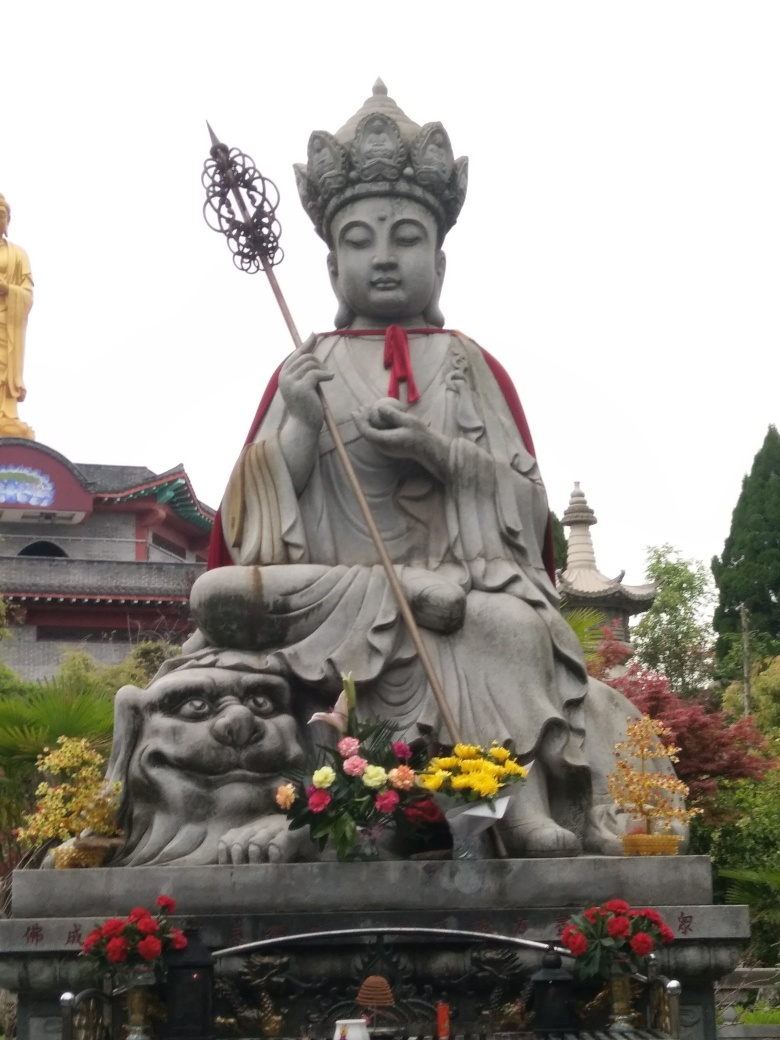Could you elaborate on the symbolism of the staff and the creature that the statue is seated upon? In many representations of Buddhist iconography, the staff held by deities or enlightened figures, such as bodhisattvas, symbolizes their ability to wield spiritual authority and the power to guide beings on the path to enlightenment. The staff may also represent the overcoming of obstacles. As for the creature at the base, it often signifies protection and support, with lion-like figures embodying strength and fearlessness. The presence of such creatures in statuary can be seen as a guardian presence, shielding the sacred space and those within it from negative influences. 